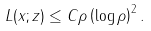<formula> <loc_0><loc_0><loc_500><loc_500>L ( x ; z ) \leq C \rho \left ( \log \rho \right ) ^ { 2 } .</formula> 